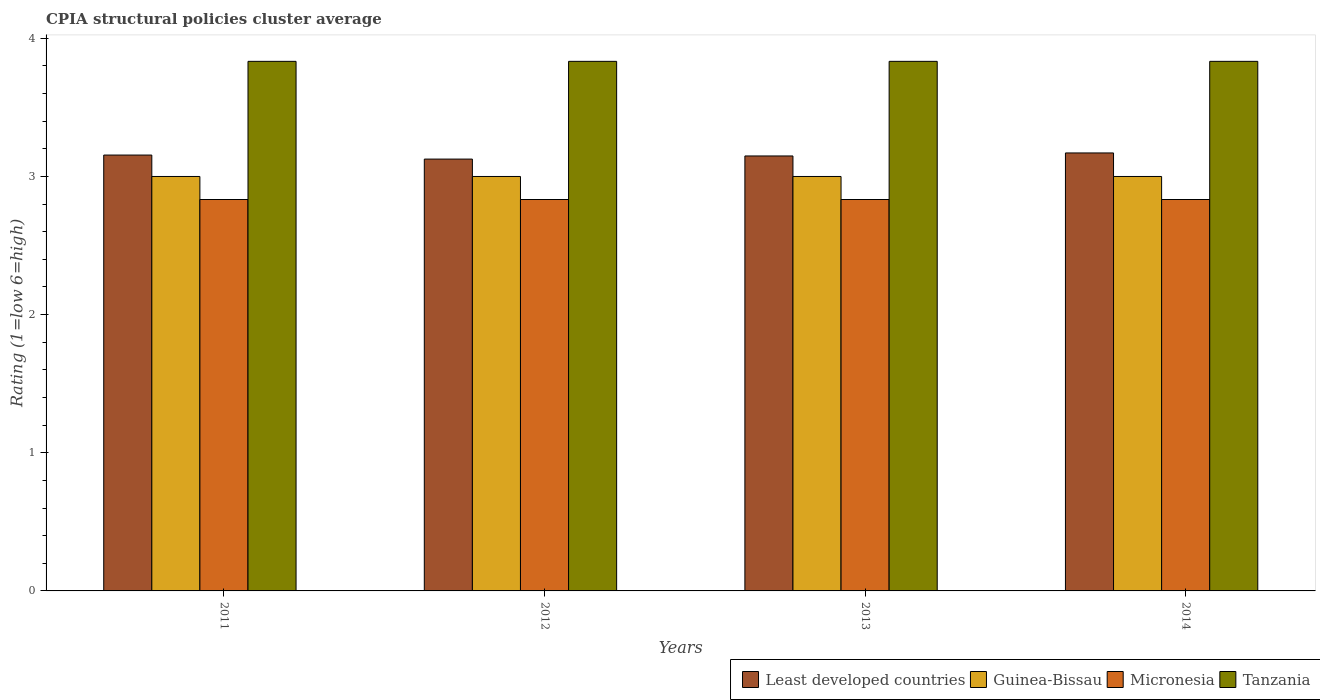How many different coloured bars are there?
Your response must be concise. 4. Are the number of bars on each tick of the X-axis equal?
Provide a short and direct response. Yes. How many bars are there on the 3rd tick from the right?
Make the answer very short. 4. What is the label of the 4th group of bars from the left?
Provide a short and direct response. 2014. In how many cases, is the number of bars for a given year not equal to the number of legend labels?
Your answer should be compact. 0. Across all years, what is the maximum CPIA rating in Least developed countries?
Make the answer very short. 3.17. Across all years, what is the minimum CPIA rating in Tanzania?
Your response must be concise. 3.83. What is the total CPIA rating in Tanzania in the graph?
Provide a succinct answer. 15.33. What is the difference between the CPIA rating in Least developed countries in 2012 and that in 2013?
Make the answer very short. -0.02. What is the difference between the CPIA rating in Least developed countries in 2011 and the CPIA rating in Guinea-Bissau in 2013?
Your answer should be compact. 0.16. What is the average CPIA rating in Guinea-Bissau per year?
Provide a short and direct response. 3. In the year 2013, what is the difference between the CPIA rating in Tanzania and CPIA rating in Least developed countries?
Offer a terse response. 0.68. In how many years, is the CPIA rating in Tanzania greater than 2.8?
Offer a very short reply. 4. What is the ratio of the CPIA rating in Tanzania in 2011 to that in 2013?
Offer a terse response. 1. Is the CPIA rating in Tanzania in 2012 less than that in 2014?
Your answer should be compact. No. Is the difference between the CPIA rating in Tanzania in 2011 and 2014 greater than the difference between the CPIA rating in Least developed countries in 2011 and 2014?
Provide a succinct answer. Yes. What is the difference between the highest and the second highest CPIA rating in Least developed countries?
Offer a very short reply. 0.02. What is the difference between the highest and the lowest CPIA rating in Least developed countries?
Keep it short and to the point. 0.04. In how many years, is the CPIA rating in Least developed countries greater than the average CPIA rating in Least developed countries taken over all years?
Your answer should be very brief. 2. Is the sum of the CPIA rating in Micronesia in 2012 and 2013 greater than the maximum CPIA rating in Least developed countries across all years?
Offer a terse response. Yes. Is it the case that in every year, the sum of the CPIA rating in Guinea-Bissau and CPIA rating in Micronesia is greater than the sum of CPIA rating in Tanzania and CPIA rating in Least developed countries?
Your answer should be very brief. No. What does the 3rd bar from the left in 2011 represents?
Offer a very short reply. Micronesia. What does the 2nd bar from the right in 2011 represents?
Provide a succinct answer. Micronesia. Is it the case that in every year, the sum of the CPIA rating in Guinea-Bissau and CPIA rating in Micronesia is greater than the CPIA rating in Least developed countries?
Your answer should be compact. Yes. How many bars are there?
Provide a succinct answer. 16. How many years are there in the graph?
Provide a succinct answer. 4. Are the values on the major ticks of Y-axis written in scientific E-notation?
Provide a succinct answer. No. Does the graph contain any zero values?
Your answer should be compact. No. How are the legend labels stacked?
Provide a short and direct response. Horizontal. What is the title of the graph?
Provide a short and direct response. CPIA structural policies cluster average. What is the Rating (1=low 6=high) of Least developed countries in 2011?
Keep it short and to the point. 3.16. What is the Rating (1=low 6=high) in Micronesia in 2011?
Give a very brief answer. 2.83. What is the Rating (1=low 6=high) in Tanzania in 2011?
Ensure brevity in your answer.  3.83. What is the Rating (1=low 6=high) of Least developed countries in 2012?
Give a very brief answer. 3.13. What is the Rating (1=low 6=high) in Guinea-Bissau in 2012?
Give a very brief answer. 3. What is the Rating (1=low 6=high) in Micronesia in 2012?
Your answer should be compact. 2.83. What is the Rating (1=low 6=high) of Tanzania in 2012?
Make the answer very short. 3.83. What is the Rating (1=low 6=high) in Least developed countries in 2013?
Keep it short and to the point. 3.15. What is the Rating (1=low 6=high) in Micronesia in 2013?
Your answer should be very brief. 2.83. What is the Rating (1=low 6=high) of Tanzania in 2013?
Ensure brevity in your answer.  3.83. What is the Rating (1=low 6=high) of Least developed countries in 2014?
Provide a succinct answer. 3.17. What is the Rating (1=low 6=high) in Micronesia in 2014?
Make the answer very short. 2.83. What is the Rating (1=low 6=high) in Tanzania in 2014?
Make the answer very short. 3.83. Across all years, what is the maximum Rating (1=low 6=high) of Least developed countries?
Your response must be concise. 3.17. Across all years, what is the maximum Rating (1=low 6=high) of Micronesia?
Give a very brief answer. 2.83. Across all years, what is the maximum Rating (1=low 6=high) of Tanzania?
Give a very brief answer. 3.83. Across all years, what is the minimum Rating (1=low 6=high) in Least developed countries?
Make the answer very short. 3.13. Across all years, what is the minimum Rating (1=low 6=high) of Guinea-Bissau?
Provide a short and direct response. 3. Across all years, what is the minimum Rating (1=low 6=high) in Micronesia?
Your answer should be compact. 2.83. Across all years, what is the minimum Rating (1=low 6=high) in Tanzania?
Offer a terse response. 3.83. What is the total Rating (1=low 6=high) of Least developed countries in the graph?
Give a very brief answer. 12.6. What is the total Rating (1=low 6=high) in Micronesia in the graph?
Your response must be concise. 11.33. What is the total Rating (1=low 6=high) of Tanzania in the graph?
Offer a terse response. 15.33. What is the difference between the Rating (1=low 6=high) in Least developed countries in 2011 and that in 2012?
Ensure brevity in your answer.  0.03. What is the difference between the Rating (1=low 6=high) of Micronesia in 2011 and that in 2012?
Offer a very short reply. 0. What is the difference between the Rating (1=low 6=high) of Tanzania in 2011 and that in 2012?
Ensure brevity in your answer.  0. What is the difference between the Rating (1=low 6=high) of Least developed countries in 2011 and that in 2013?
Offer a very short reply. 0.01. What is the difference between the Rating (1=low 6=high) of Least developed countries in 2011 and that in 2014?
Offer a very short reply. -0.02. What is the difference between the Rating (1=low 6=high) in Guinea-Bissau in 2011 and that in 2014?
Your answer should be very brief. 0. What is the difference between the Rating (1=low 6=high) of Micronesia in 2011 and that in 2014?
Give a very brief answer. 0. What is the difference between the Rating (1=low 6=high) in Least developed countries in 2012 and that in 2013?
Make the answer very short. -0.02. What is the difference between the Rating (1=low 6=high) of Micronesia in 2012 and that in 2013?
Ensure brevity in your answer.  0. What is the difference between the Rating (1=low 6=high) of Tanzania in 2012 and that in 2013?
Make the answer very short. 0. What is the difference between the Rating (1=low 6=high) in Least developed countries in 2012 and that in 2014?
Keep it short and to the point. -0.04. What is the difference between the Rating (1=low 6=high) in Guinea-Bissau in 2012 and that in 2014?
Make the answer very short. 0. What is the difference between the Rating (1=low 6=high) of Micronesia in 2012 and that in 2014?
Provide a short and direct response. 0. What is the difference between the Rating (1=low 6=high) in Tanzania in 2012 and that in 2014?
Ensure brevity in your answer.  0. What is the difference between the Rating (1=low 6=high) in Least developed countries in 2013 and that in 2014?
Give a very brief answer. -0.02. What is the difference between the Rating (1=low 6=high) of Least developed countries in 2011 and the Rating (1=low 6=high) of Guinea-Bissau in 2012?
Provide a succinct answer. 0.15. What is the difference between the Rating (1=low 6=high) in Least developed countries in 2011 and the Rating (1=low 6=high) in Micronesia in 2012?
Provide a short and direct response. 0.32. What is the difference between the Rating (1=low 6=high) in Least developed countries in 2011 and the Rating (1=low 6=high) in Tanzania in 2012?
Give a very brief answer. -0.68. What is the difference between the Rating (1=low 6=high) in Least developed countries in 2011 and the Rating (1=low 6=high) in Guinea-Bissau in 2013?
Your response must be concise. 0.15. What is the difference between the Rating (1=low 6=high) in Least developed countries in 2011 and the Rating (1=low 6=high) in Micronesia in 2013?
Offer a terse response. 0.32. What is the difference between the Rating (1=low 6=high) in Least developed countries in 2011 and the Rating (1=low 6=high) in Tanzania in 2013?
Provide a succinct answer. -0.68. What is the difference between the Rating (1=low 6=high) of Guinea-Bissau in 2011 and the Rating (1=low 6=high) of Micronesia in 2013?
Give a very brief answer. 0.17. What is the difference between the Rating (1=low 6=high) in Guinea-Bissau in 2011 and the Rating (1=low 6=high) in Tanzania in 2013?
Your response must be concise. -0.83. What is the difference between the Rating (1=low 6=high) of Least developed countries in 2011 and the Rating (1=low 6=high) of Guinea-Bissau in 2014?
Make the answer very short. 0.15. What is the difference between the Rating (1=low 6=high) of Least developed countries in 2011 and the Rating (1=low 6=high) of Micronesia in 2014?
Offer a terse response. 0.32. What is the difference between the Rating (1=low 6=high) in Least developed countries in 2011 and the Rating (1=low 6=high) in Tanzania in 2014?
Offer a terse response. -0.68. What is the difference between the Rating (1=low 6=high) in Guinea-Bissau in 2011 and the Rating (1=low 6=high) in Micronesia in 2014?
Give a very brief answer. 0.17. What is the difference between the Rating (1=low 6=high) of Guinea-Bissau in 2011 and the Rating (1=low 6=high) of Tanzania in 2014?
Provide a succinct answer. -0.83. What is the difference between the Rating (1=low 6=high) of Least developed countries in 2012 and the Rating (1=low 6=high) of Guinea-Bissau in 2013?
Your answer should be very brief. 0.13. What is the difference between the Rating (1=low 6=high) in Least developed countries in 2012 and the Rating (1=low 6=high) in Micronesia in 2013?
Offer a very short reply. 0.29. What is the difference between the Rating (1=low 6=high) of Least developed countries in 2012 and the Rating (1=low 6=high) of Tanzania in 2013?
Your answer should be compact. -0.71. What is the difference between the Rating (1=low 6=high) in Guinea-Bissau in 2012 and the Rating (1=low 6=high) in Micronesia in 2013?
Offer a terse response. 0.17. What is the difference between the Rating (1=low 6=high) in Guinea-Bissau in 2012 and the Rating (1=low 6=high) in Tanzania in 2013?
Your answer should be very brief. -0.83. What is the difference between the Rating (1=low 6=high) of Least developed countries in 2012 and the Rating (1=low 6=high) of Guinea-Bissau in 2014?
Offer a very short reply. 0.13. What is the difference between the Rating (1=low 6=high) in Least developed countries in 2012 and the Rating (1=low 6=high) in Micronesia in 2014?
Your answer should be compact. 0.29. What is the difference between the Rating (1=low 6=high) in Least developed countries in 2012 and the Rating (1=low 6=high) in Tanzania in 2014?
Make the answer very short. -0.71. What is the difference between the Rating (1=low 6=high) of Guinea-Bissau in 2012 and the Rating (1=low 6=high) of Tanzania in 2014?
Keep it short and to the point. -0.83. What is the difference between the Rating (1=low 6=high) in Least developed countries in 2013 and the Rating (1=low 6=high) in Guinea-Bissau in 2014?
Your answer should be compact. 0.15. What is the difference between the Rating (1=low 6=high) of Least developed countries in 2013 and the Rating (1=low 6=high) of Micronesia in 2014?
Make the answer very short. 0.32. What is the difference between the Rating (1=low 6=high) in Least developed countries in 2013 and the Rating (1=low 6=high) in Tanzania in 2014?
Ensure brevity in your answer.  -0.68. What is the average Rating (1=low 6=high) of Least developed countries per year?
Provide a short and direct response. 3.15. What is the average Rating (1=low 6=high) in Guinea-Bissau per year?
Offer a terse response. 3. What is the average Rating (1=low 6=high) in Micronesia per year?
Offer a terse response. 2.83. What is the average Rating (1=low 6=high) in Tanzania per year?
Give a very brief answer. 3.83. In the year 2011, what is the difference between the Rating (1=low 6=high) in Least developed countries and Rating (1=low 6=high) in Guinea-Bissau?
Provide a succinct answer. 0.15. In the year 2011, what is the difference between the Rating (1=low 6=high) in Least developed countries and Rating (1=low 6=high) in Micronesia?
Offer a terse response. 0.32. In the year 2011, what is the difference between the Rating (1=low 6=high) in Least developed countries and Rating (1=low 6=high) in Tanzania?
Offer a very short reply. -0.68. In the year 2012, what is the difference between the Rating (1=low 6=high) in Least developed countries and Rating (1=low 6=high) in Guinea-Bissau?
Offer a terse response. 0.13. In the year 2012, what is the difference between the Rating (1=low 6=high) of Least developed countries and Rating (1=low 6=high) of Micronesia?
Give a very brief answer. 0.29. In the year 2012, what is the difference between the Rating (1=low 6=high) in Least developed countries and Rating (1=low 6=high) in Tanzania?
Provide a short and direct response. -0.71. In the year 2012, what is the difference between the Rating (1=low 6=high) in Guinea-Bissau and Rating (1=low 6=high) in Tanzania?
Provide a succinct answer. -0.83. In the year 2013, what is the difference between the Rating (1=low 6=high) in Least developed countries and Rating (1=low 6=high) in Guinea-Bissau?
Your answer should be compact. 0.15. In the year 2013, what is the difference between the Rating (1=low 6=high) of Least developed countries and Rating (1=low 6=high) of Micronesia?
Give a very brief answer. 0.32. In the year 2013, what is the difference between the Rating (1=low 6=high) in Least developed countries and Rating (1=low 6=high) in Tanzania?
Offer a terse response. -0.68. In the year 2013, what is the difference between the Rating (1=low 6=high) of Micronesia and Rating (1=low 6=high) of Tanzania?
Make the answer very short. -1. In the year 2014, what is the difference between the Rating (1=low 6=high) in Least developed countries and Rating (1=low 6=high) in Guinea-Bissau?
Ensure brevity in your answer.  0.17. In the year 2014, what is the difference between the Rating (1=low 6=high) in Least developed countries and Rating (1=low 6=high) in Micronesia?
Make the answer very short. 0.34. In the year 2014, what is the difference between the Rating (1=low 6=high) of Least developed countries and Rating (1=low 6=high) of Tanzania?
Offer a very short reply. -0.66. In the year 2014, what is the difference between the Rating (1=low 6=high) in Guinea-Bissau and Rating (1=low 6=high) in Micronesia?
Provide a short and direct response. 0.17. What is the ratio of the Rating (1=low 6=high) of Least developed countries in 2011 to that in 2012?
Your response must be concise. 1.01. What is the ratio of the Rating (1=low 6=high) of Micronesia in 2011 to that in 2012?
Ensure brevity in your answer.  1. What is the ratio of the Rating (1=low 6=high) of Tanzania in 2011 to that in 2012?
Ensure brevity in your answer.  1. What is the ratio of the Rating (1=low 6=high) of Least developed countries in 2011 to that in 2013?
Make the answer very short. 1. What is the ratio of the Rating (1=low 6=high) in Guinea-Bissau in 2011 to that in 2014?
Keep it short and to the point. 1. What is the ratio of the Rating (1=low 6=high) in Micronesia in 2011 to that in 2014?
Your answer should be compact. 1. What is the ratio of the Rating (1=low 6=high) in Tanzania in 2011 to that in 2014?
Ensure brevity in your answer.  1. What is the ratio of the Rating (1=low 6=high) in Least developed countries in 2012 to that in 2013?
Your response must be concise. 0.99. What is the ratio of the Rating (1=low 6=high) in Micronesia in 2012 to that in 2013?
Your response must be concise. 1. What is the ratio of the Rating (1=low 6=high) in Tanzania in 2012 to that in 2013?
Offer a very short reply. 1. What is the ratio of the Rating (1=low 6=high) in Guinea-Bissau in 2012 to that in 2014?
Make the answer very short. 1. What is the ratio of the Rating (1=low 6=high) of Guinea-Bissau in 2013 to that in 2014?
Ensure brevity in your answer.  1. What is the ratio of the Rating (1=low 6=high) in Micronesia in 2013 to that in 2014?
Offer a very short reply. 1. What is the difference between the highest and the second highest Rating (1=low 6=high) in Least developed countries?
Offer a very short reply. 0.02. What is the difference between the highest and the second highest Rating (1=low 6=high) of Guinea-Bissau?
Offer a very short reply. 0. What is the difference between the highest and the second highest Rating (1=low 6=high) of Tanzania?
Provide a short and direct response. 0. What is the difference between the highest and the lowest Rating (1=low 6=high) of Least developed countries?
Keep it short and to the point. 0.04. What is the difference between the highest and the lowest Rating (1=low 6=high) of Guinea-Bissau?
Offer a very short reply. 0. 